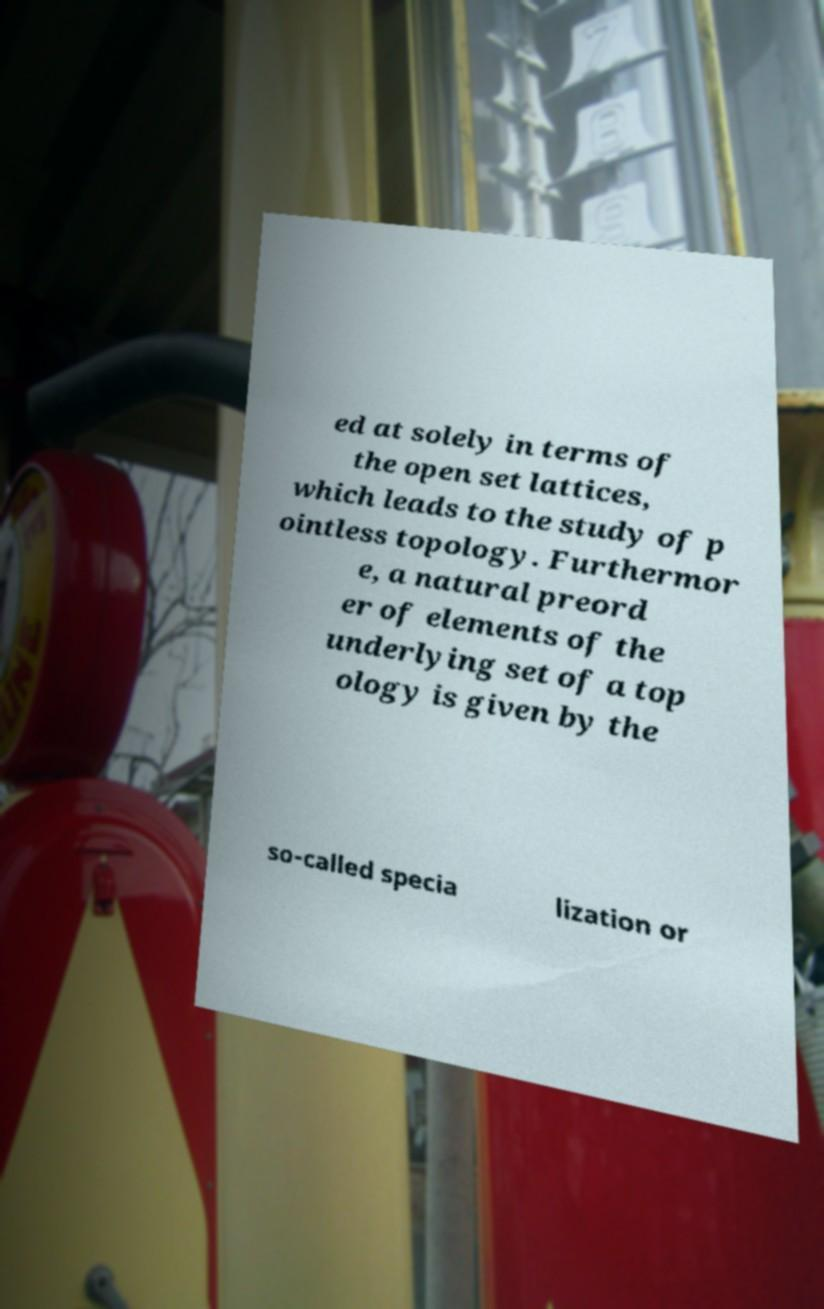What messages or text are displayed in this image? I need them in a readable, typed format. ed at solely in terms of the open set lattices, which leads to the study of p ointless topology. Furthermor e, a natural preord er of elements of the underlying set of a top ology is given by the so-called specia lization or 